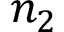Convert formula to latex. <formula><loc_0><loc_0><loc_500><loc_500>n _ { 2 }</formula> 